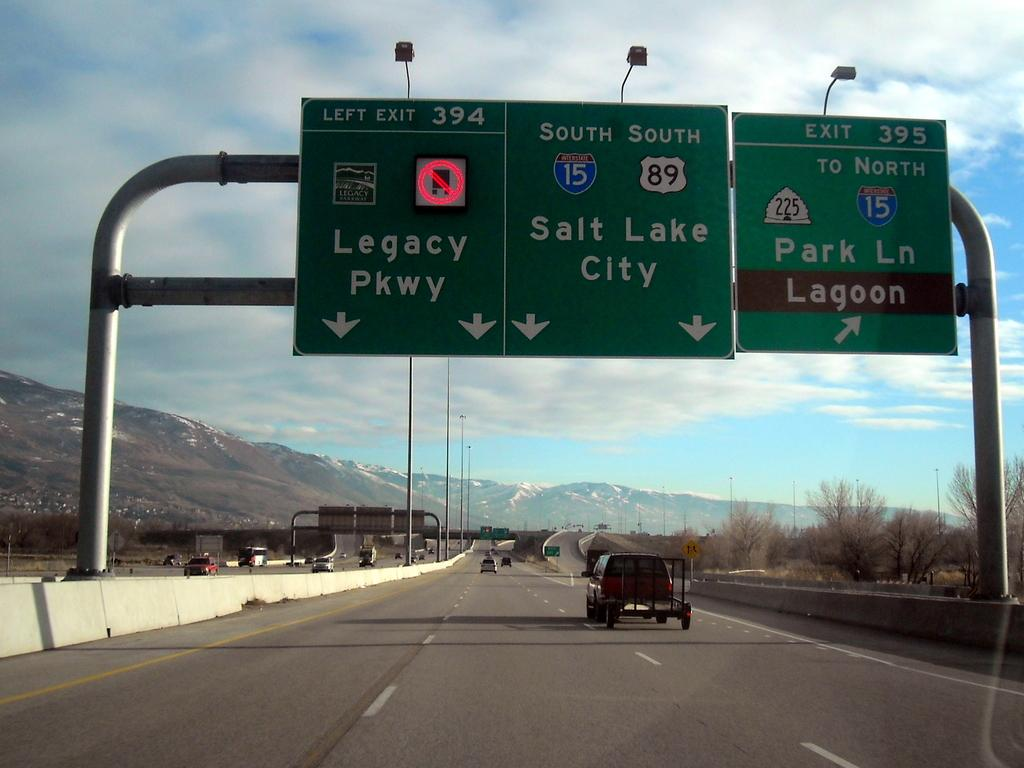<image>
Render a clear and concise summary of the photo. the words salt lake city are on a sign 